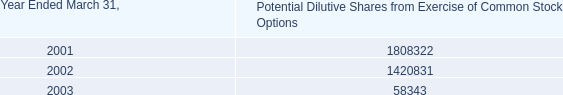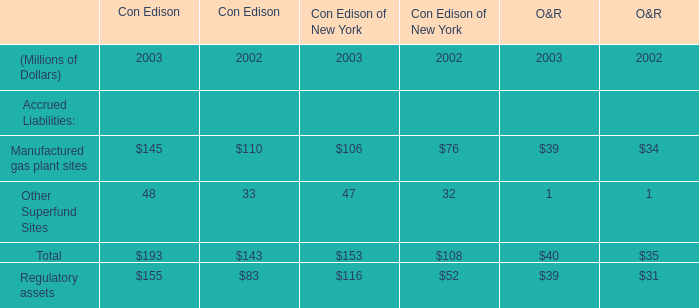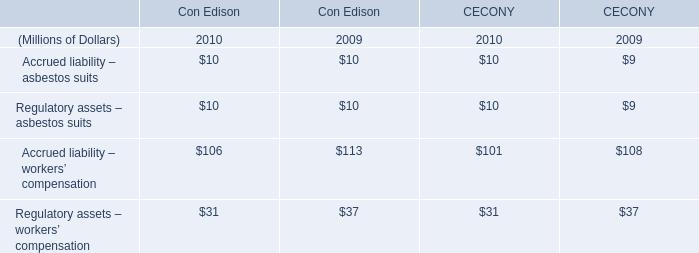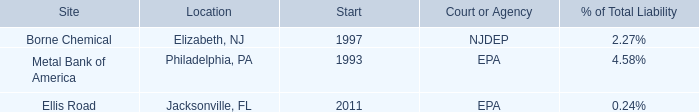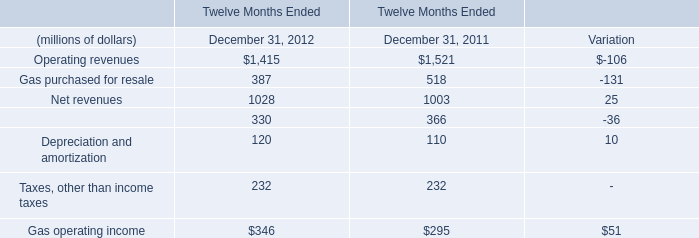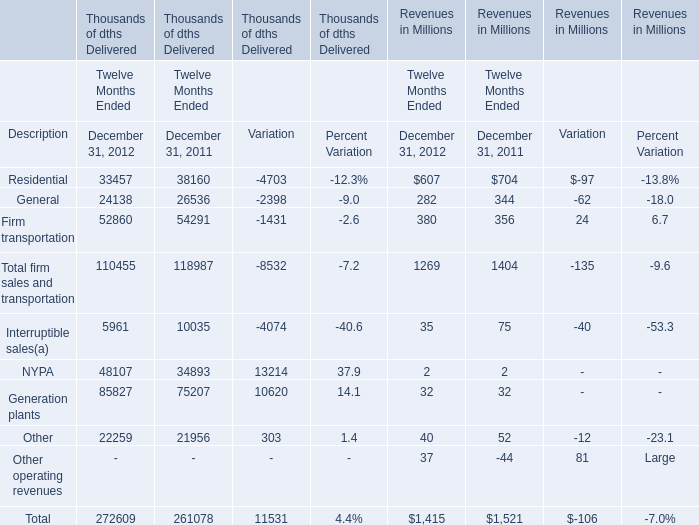What is the proportion of Gas purchased for resale to the total in 2012 for Operating revenues ? 
Computations: (387 / 1415)
Answer: 0.2735. 